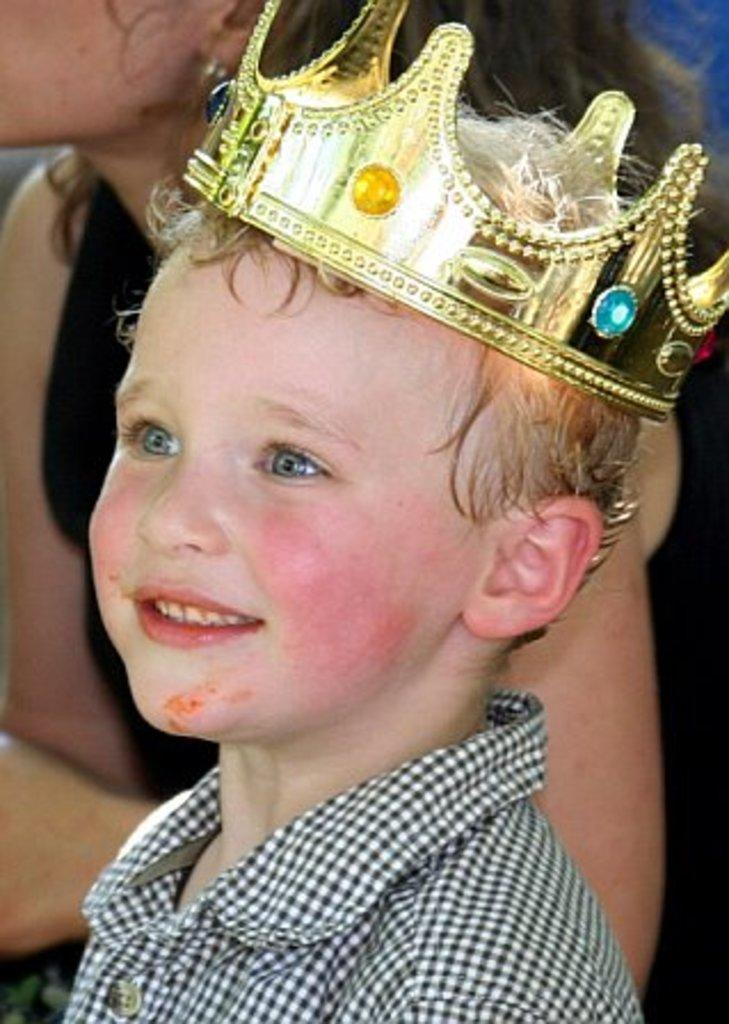Who are the people in the image? There is a boy and a woman in the image. What is the boy doing in the image? The boy is smiling in the image. What is the boy wearing in the image? The boy is wearing a crown in the image. What type of monkey can be seen playing with a coach in the image? There is no monkey or coach present in the image; it features a boy and a woman. 